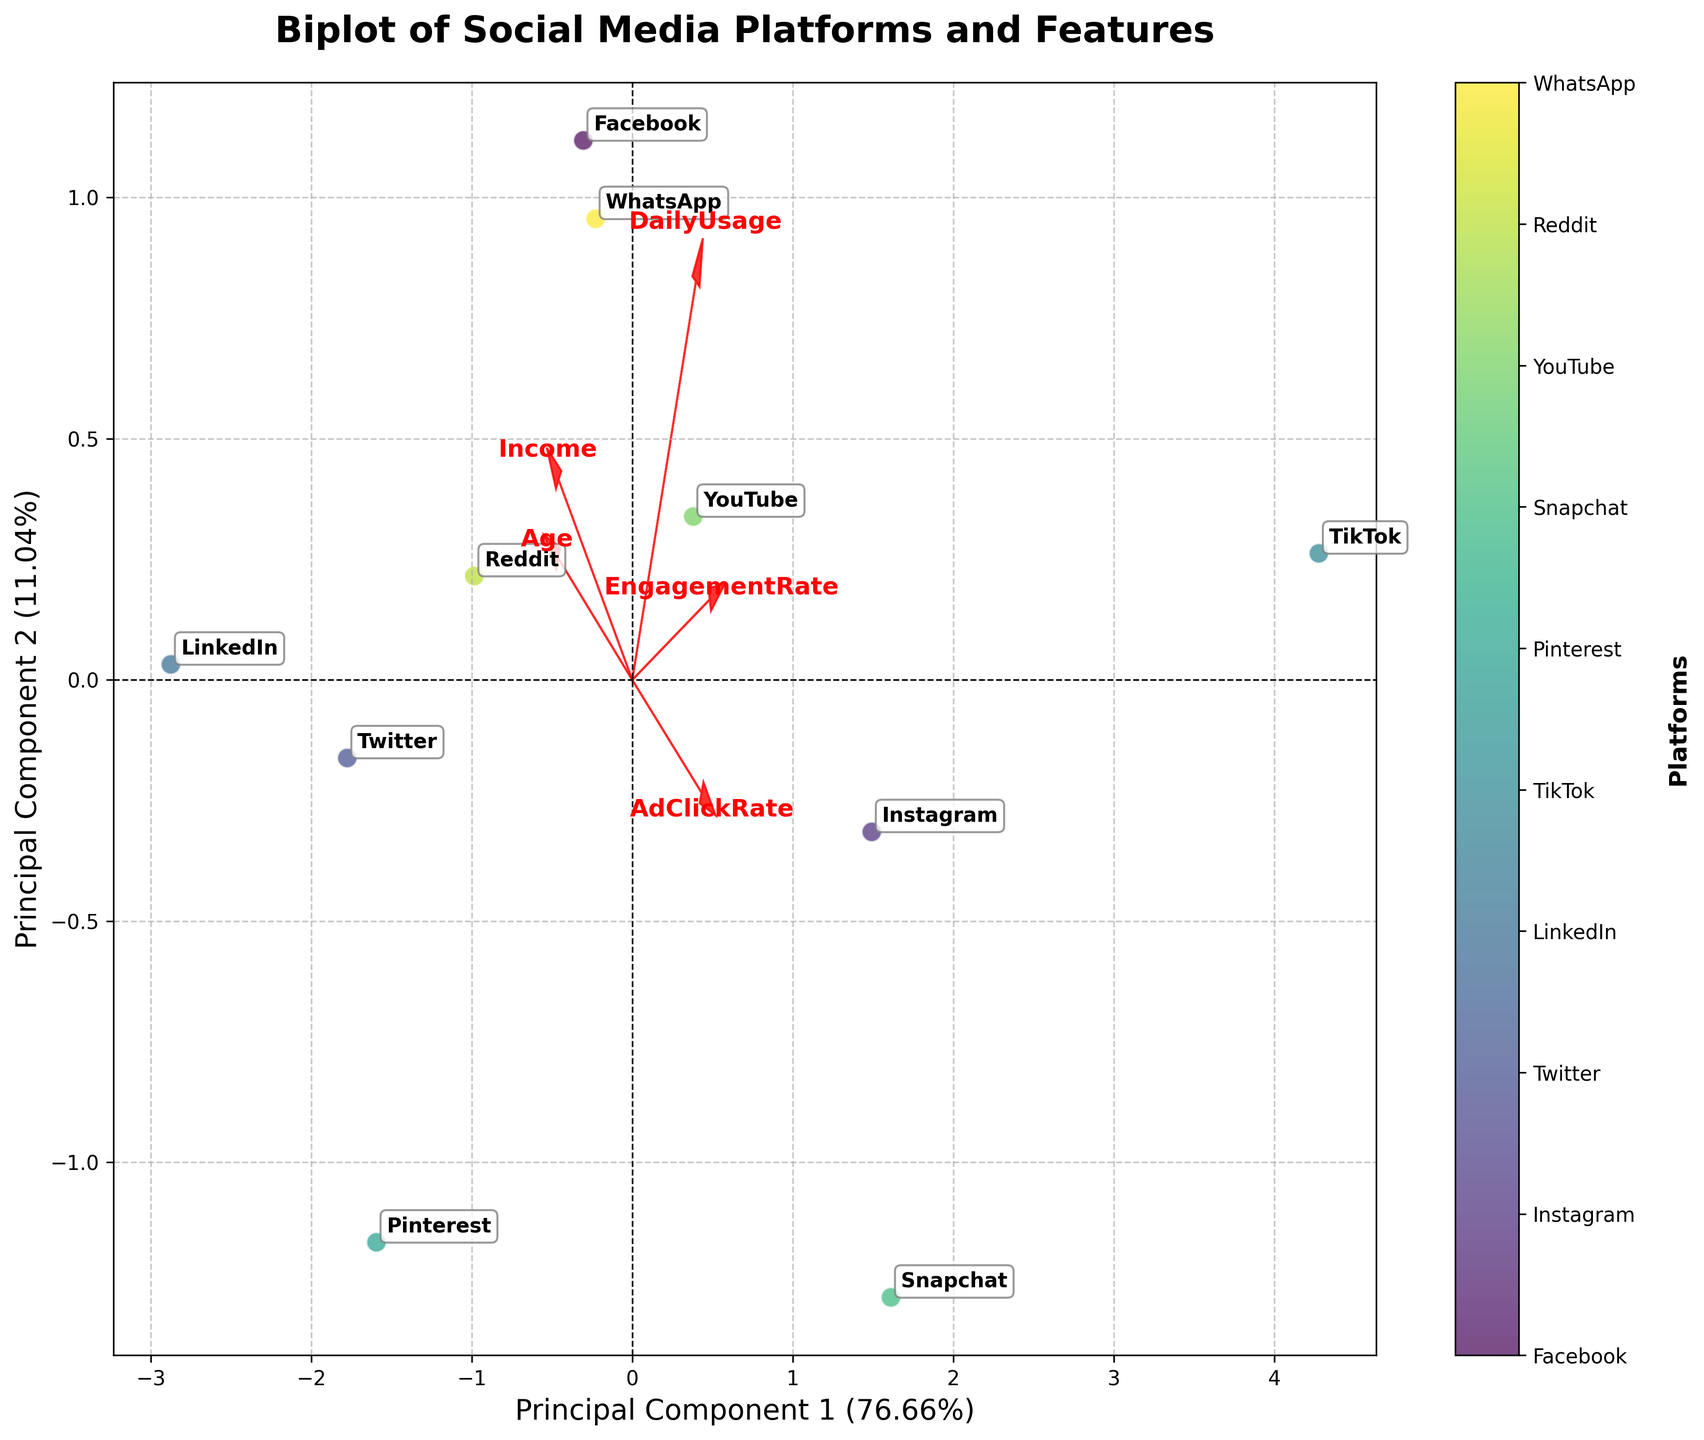Which platform is closest to the origin in the biplot? The origin (0,0) is the center of the plot. We need to look at which platform label is positioned closest to this center point.
Answer: LinkedIn Which platform is positioned furthest along the first principal component axis? The first principal component axis (PC1) is represented by the horizontal axis. The platform furthest along this axis will be at the extreme ends of this axis.
Answer: TikTok Which feature contributes most positively to the first principal component? We look at the direction and length of the arrows representing the features. The arrow pointing most positively along the first principal component axis (horizontal) indicates the feature that contributes the most.
Answer: DailyUsage What's the direction of the Income feature vector relative to the principal components? We examine the arrows for each feature. The Income feature vector's direction is important to identify its relation to PC1 and PC2.
Answer: Slightly positive along PC1 and more positive along PC2 Which platform has a high DailyUsage but a low Income? Platforms with high DailyUsage are towards the direction of the DailyUsage arrow, and those with low Income are towards the opposite direction of the Income arrow. The platform in this intersecting region is our interest.
Answer: TikTok Which two platforms are closest to each other on the biplot? We identify the pair of platform labels that are closest in the biplot in terms of their position on the graph.
Answer: YouTube and Facebook Which feature vector is most orthogonal to the Age vector? We need to identify the feature vector that forms the closest to a right angle (90-degree) with the Age vector. Orthogonality means no correlation between these two features.
Answer: EngagementRate In terms of AdClickRate and EngagementRate, which platform shows high values for both? Platforms with high values of both AdClickRate and EngagementRate will be aligned positively with both of these vectors. We look for those positioned in the space pointing in the directions of these vectors.
Answer: TikTok Which principal component explains more variance, and what percentage does it explain? We need to refer to the PCA axis labels, which indicate the percentage of variance explained by each principal component. The one with the higher percentage explains more variance.
Answer: The first principal component explains more variance, 42.8% Which platform is positioned closest to the positive direction of the AdClickRate vector? We need to identify the platform label closest to the direction in which the AdClickRate arrow points.
Answer: TikTok 